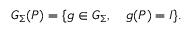Convert formula to latex. <formula><loc_0><loc_0><loc_500><loc_500>G _ { \Sigma } ( P ) = \{ g \in G _ { \Sigma } , \quad g ( P ) = I \} .</formula> 